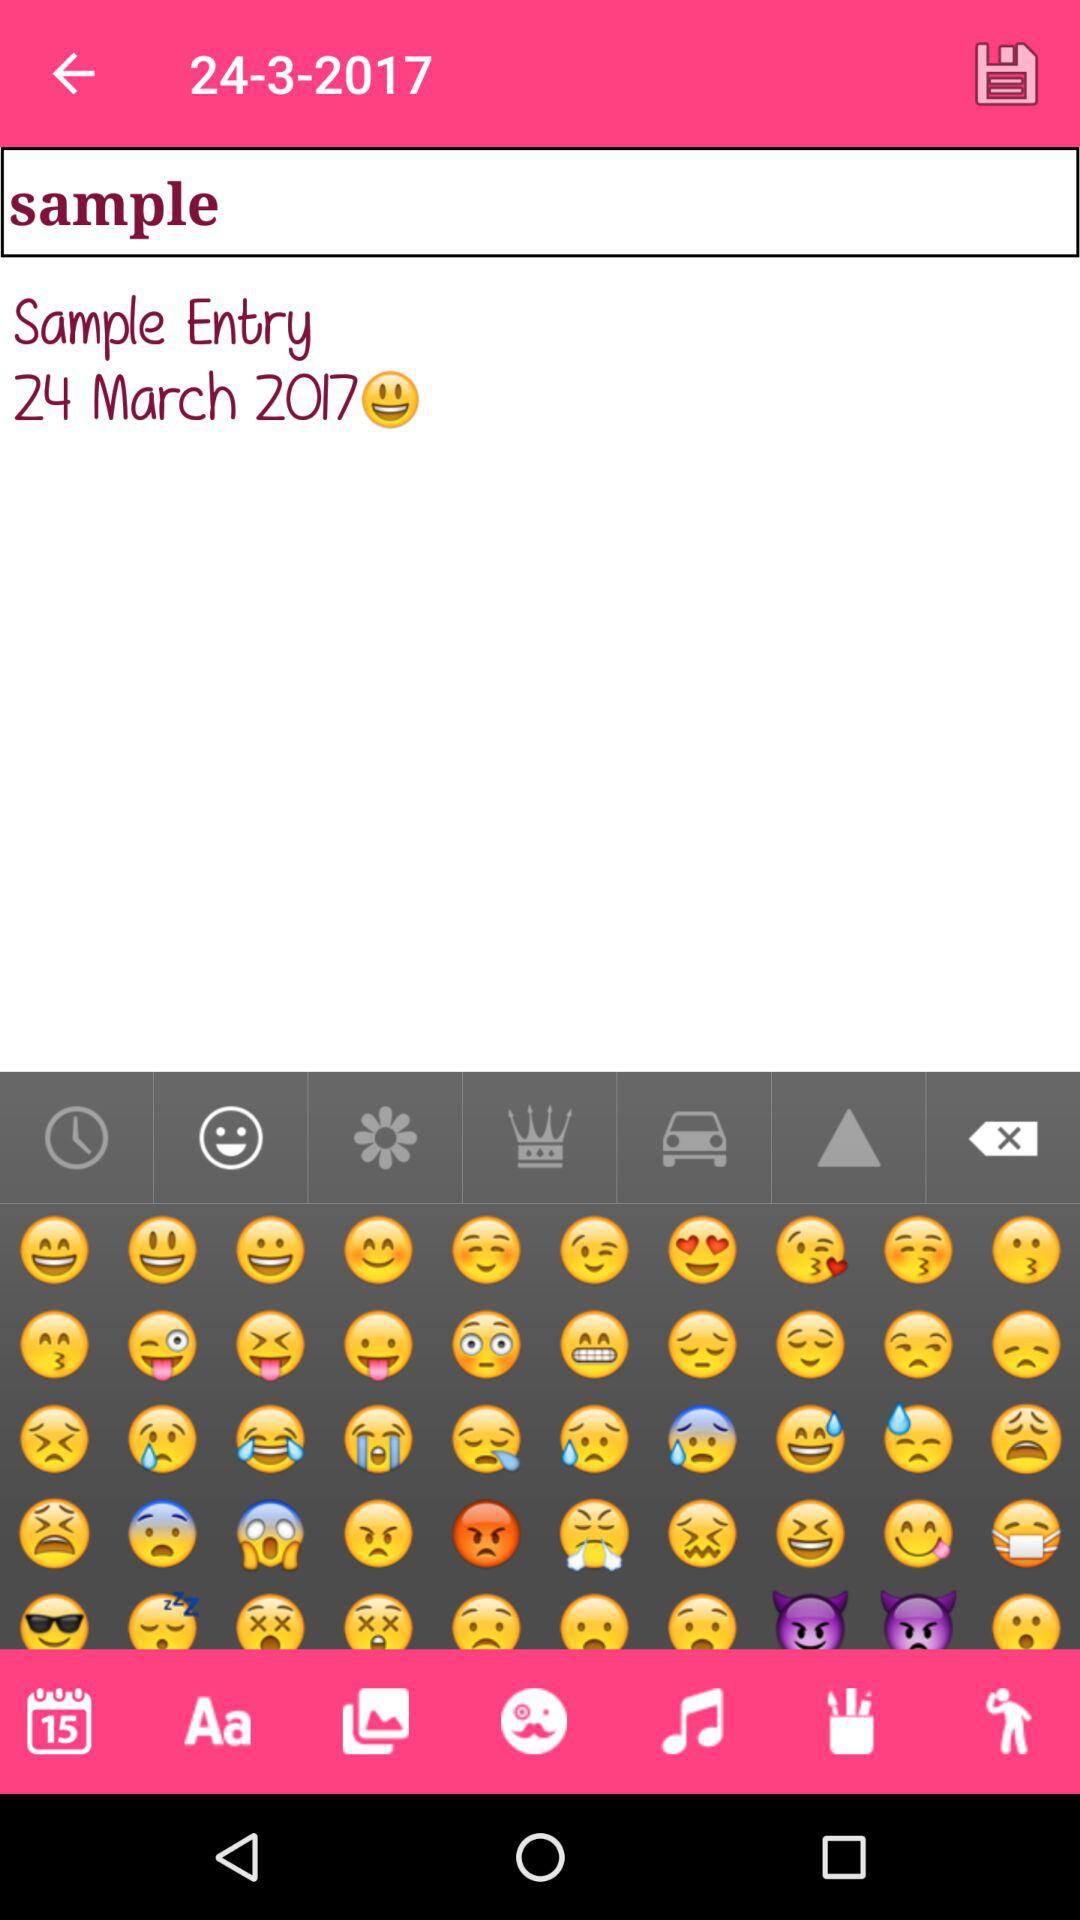What is the displayed date on the screen? The displayed date is March 24, 2017. 